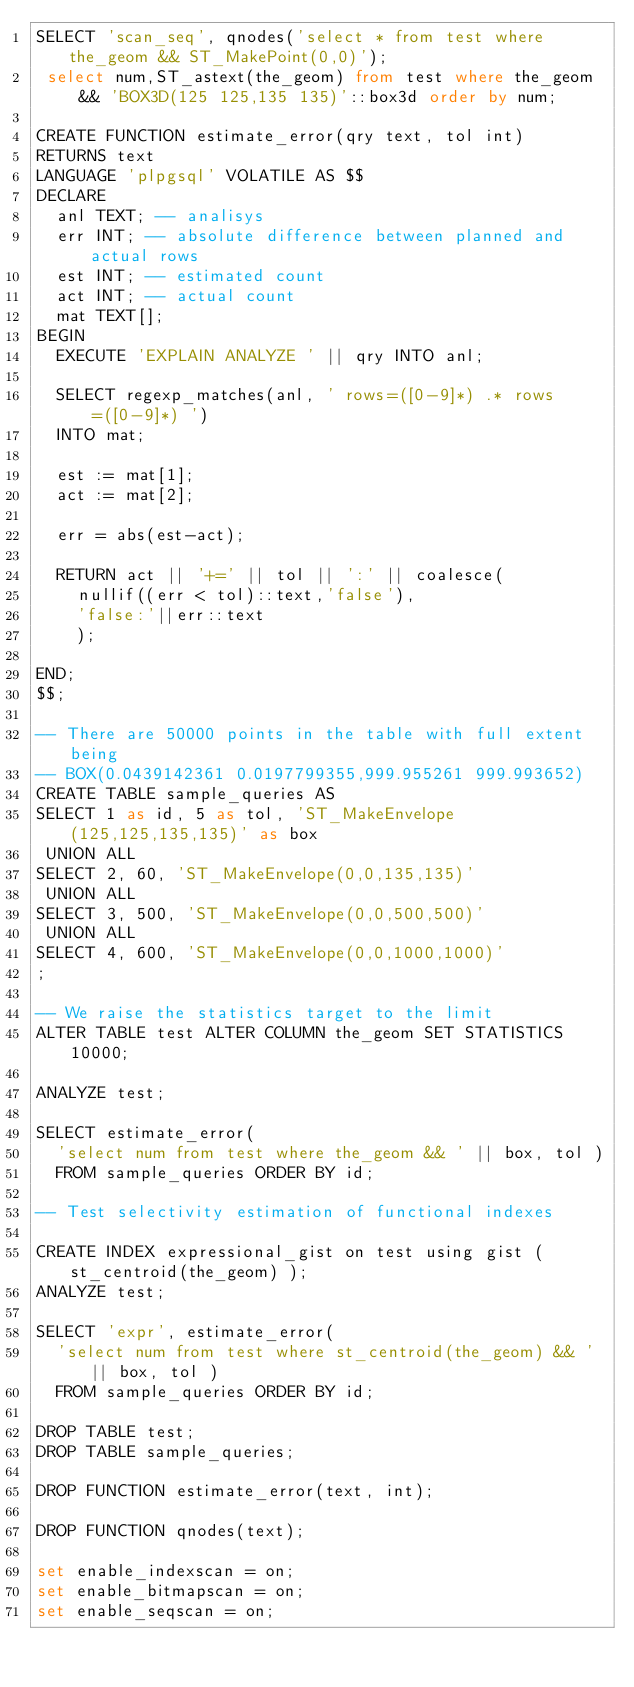<code> <loc_0><loc_0><loc_500><loc_500><_SQL_>SELECT 'scan_seq', qnodes('select * from test where the_geom && ST_MakePoint(0,0)');
 select num,ST_astext(the_geom) from test where the_geom && 'BOX3D(125 125,135 135)'::box3d order by num;

CREATE FUNCTION estimate_error(qry text, tol int)
RETURNS text
LANGUAGE 'plpgsql' VOLATILE AS $$
DECLARE
  anl TEXT; -- analisys
  err INT; -- absolute difference between planned and actual rows
  est INT; -- estimated count
  act INT; -- actual count
  mat TEXT[];
BEGIN
  EXECUTE 'EXPLAIN ANALYZE ' || qry INTO anl;

  SELECT regexp_matches(anl, ' rows=([0-9]*) .* rows=([0-9]*) ')
  INTO mat;

  est := mat[1];
  act := mat[2];
    
  err = abs(est-act);

  RETURN act || '+=' || tol || ':' || coalesce(
    nullif((err < tol)::text,'false'),
    'false:'||err::text
    );

END;
$$;

-- There are 50000 points in the table with full extent being
-- BOX(0.0439142361 0.0197799355,999.955261 999.993652)
CREATE TABLE sample_queries AS
SELECT 1 as id, 5 as tol, 'ST_MakeEnvelope(125,125,135,135)' as box
 UNION ALL
SELECT 2, 60, 'ST_MakeEnvelope(0,0,135,135)'
 UNION ALL
SELECT 3, 500, 'ST_MakeEnvelope(0,0,500,500)'
 UNION ALL
SELECT 4, 600, 'ST_MakeEnvelope(0,0,1000,1000)'
;

-- We raise the statistics target to the limit 
ALTER TABLE test ALTER COLUMN the_geom SET STATISTICS 10000;

ANALYZE test;

SELECT estimate_error(
  'select num from test where the_geom && ' || box, tol )
  FROM sample_queries ORDER BY id;

-- Test selectivity estimation of functional indexes

CREATE INDEX expressional_gist on test using gist ( st_centroid(the_geom) );
ANALYZE test;

SELECT 'expr', estimate_error(
  'select num from test where st_centroid(the_geom) && ' || box, tol )
  FROM sample_queries ORDER BY id;

DROP TABLE test;
DROP TABLE sample_queries;

DROP FUNCTION estimate_error(text, int);

DROP FUNCTION qnodes(text);

set enable_indexscan = on;
set enable_bitmapscan = on;
set enable_seqscan = on;
</code> 